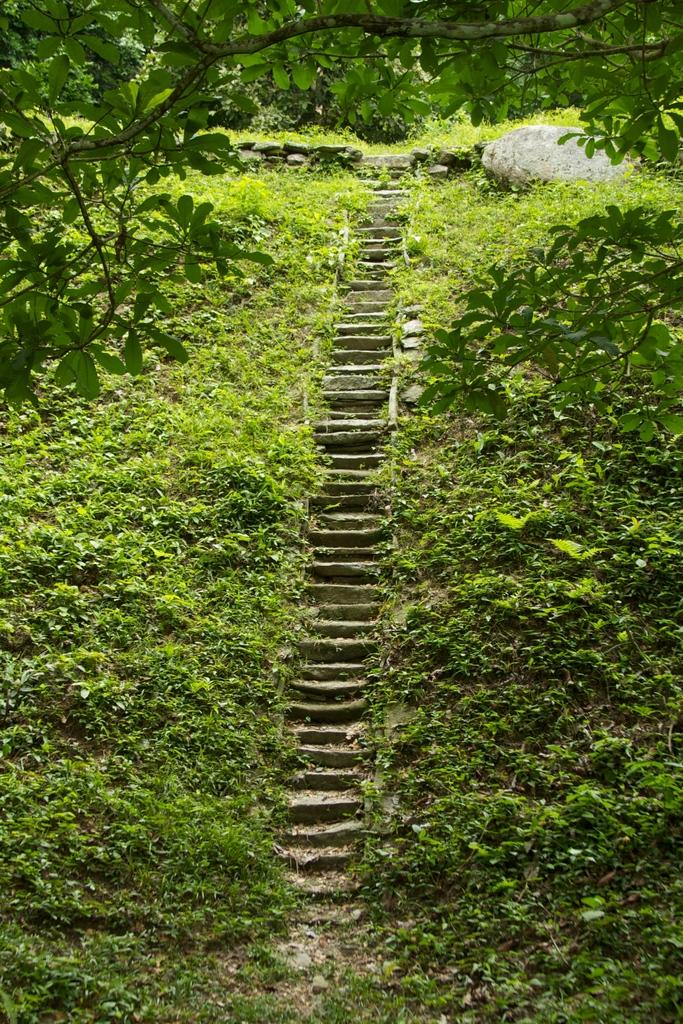What type of structure is located in the middle of the image? There are stone steps in the middle of the image. What can be seen beside the stone steps? There are plants beside the steps. What is located on the right side of the image? There is a big stone on the ground on the right side of the image. What type of basin is visible at the top of the stone steps in the image? There is no basin visible at the top of the stone steps in the image. What experience can be gained by walking on the stone steps in the image? The image does not convey any specific experience that can be gained by walking on the stone steps. 